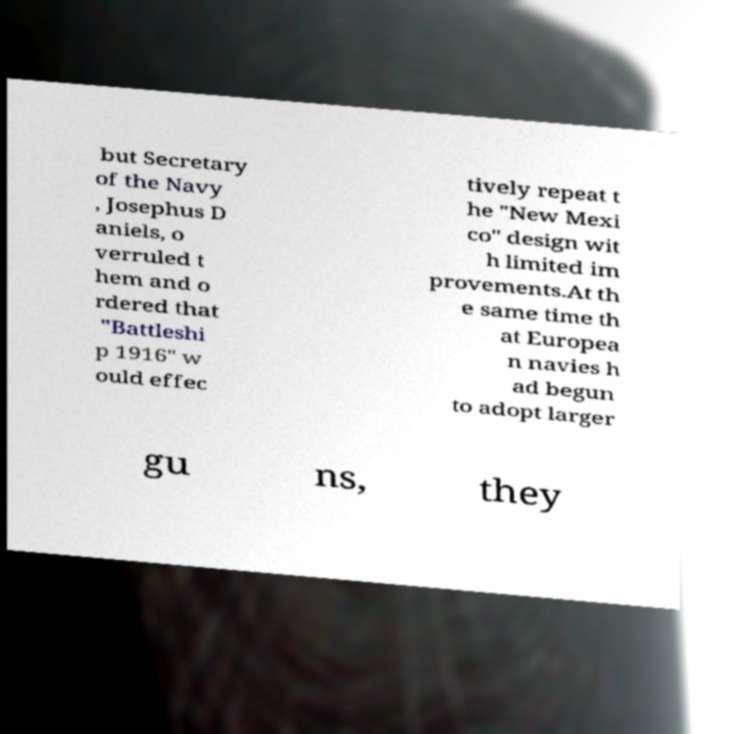Please identify and transcribe the text found in this image. but Secretary of the Navy , Josephus D aniels, o verruled t hem and o rdered that "Battleshi p 1916" w ould effec tively repeat t he "New Mexi co" design wit h limited im provements.At th e same time th at Europea n navies h ad begun to adopt larger gu ns, they 